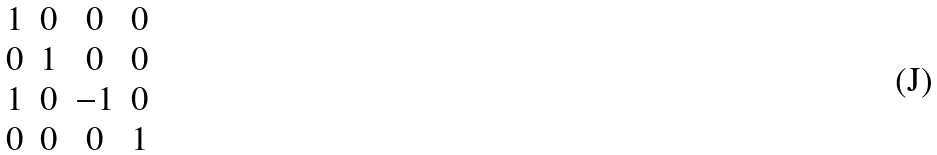Convert formula to latex. <formula><loc_0><loc_0><loc_500><loc_500>\begin{matrix} 1 & 0 & 0 & 0 \\ 0 & 1 & 0 & 0 \\ 1 & 0 & - 1 & 0 \\ 0 & 0 & 0 & 1 \end{matrix}</formula> 